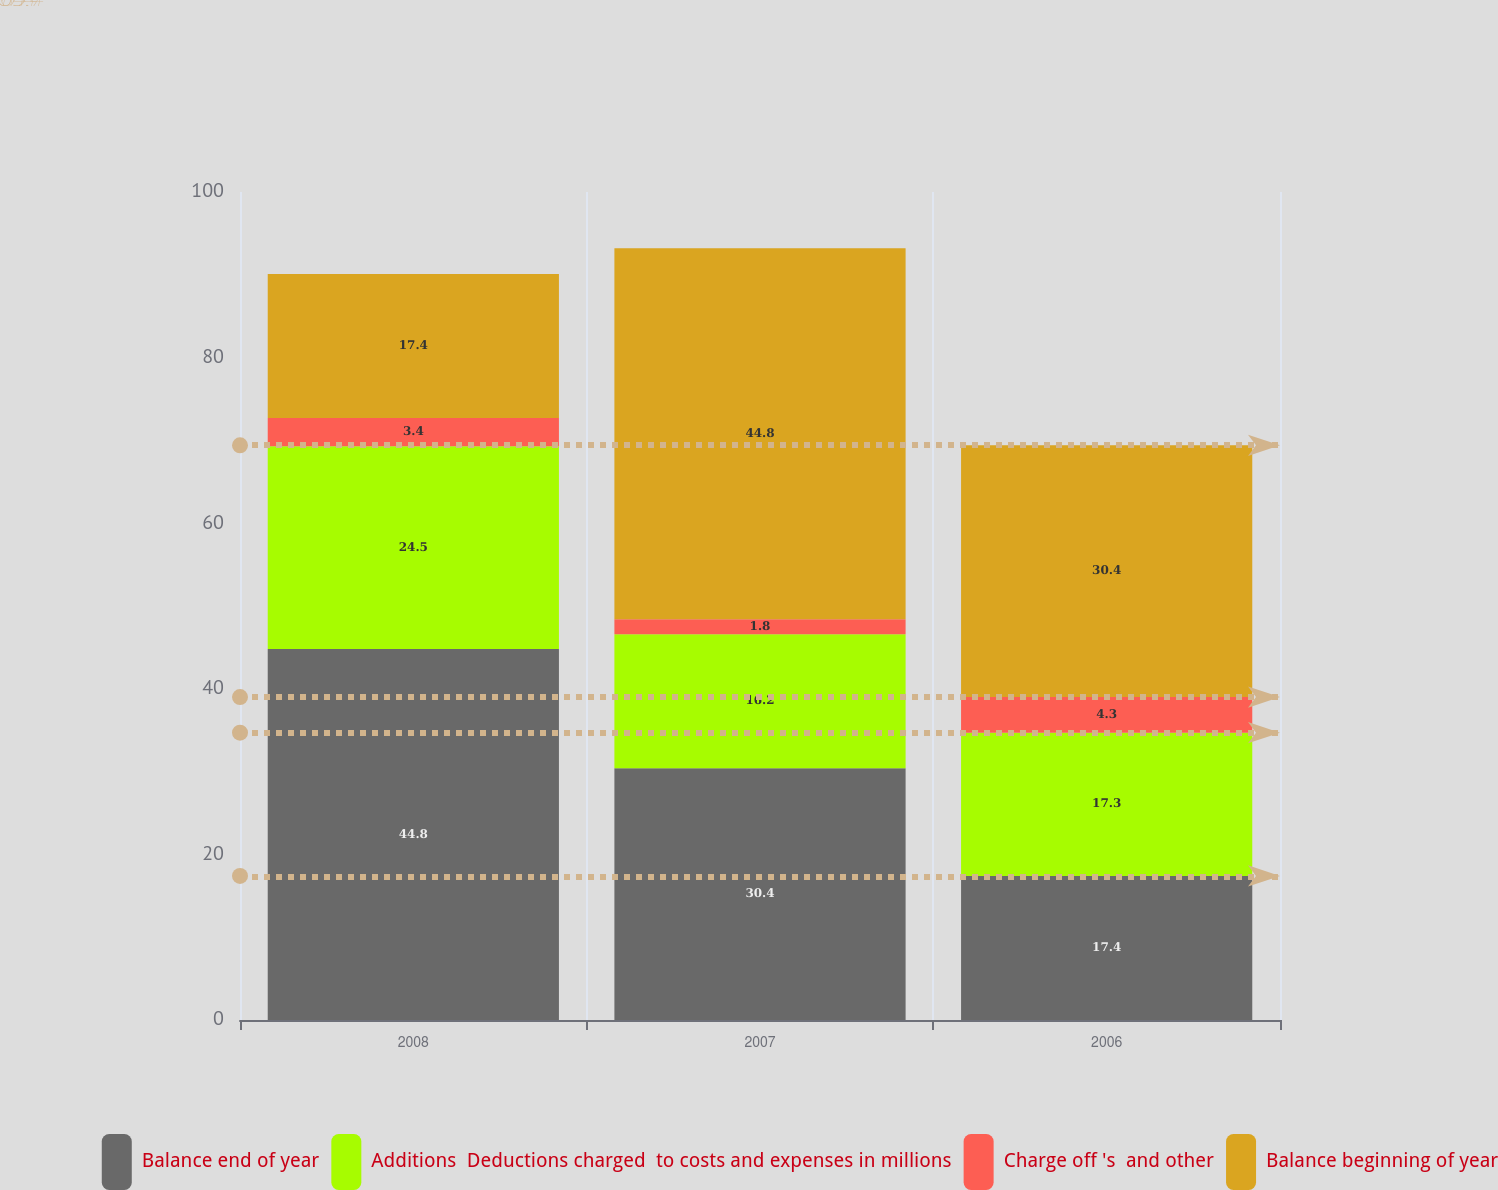<chart> <loc_0><loc_0><loc_500><loc_500><stacked_bar_chart><ecel><fcel>2008<fcel>2007<fcel>2006<nl><fcel>Balance end of year<fcel>44.8<fcel>30.4<fcel>17.4<nl><fcel>Additions  Deductions charged  to costs and expenses in millions<fcel>24.5<fcel>16.2<fcel>17.3<nl><fcel>Charge off 's  and other<fcel>3.4<fcel>1.8<fcel>4.3<nl><fcel>Balance beginning of year<fcel>17.4<fcel>44.8<fcel>30.4<nl></chart> 